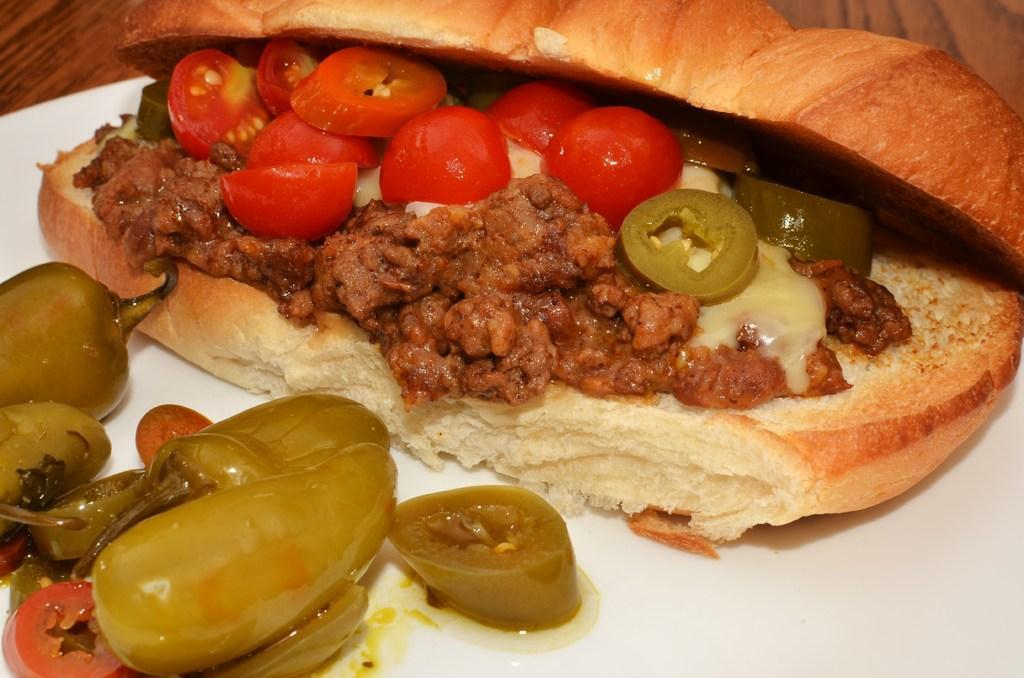Please provide a concise description of this image. In this image I can see a white colored plate on the brown colored table. In the plate I can see a food item which is brown, cream, red and green in color. 